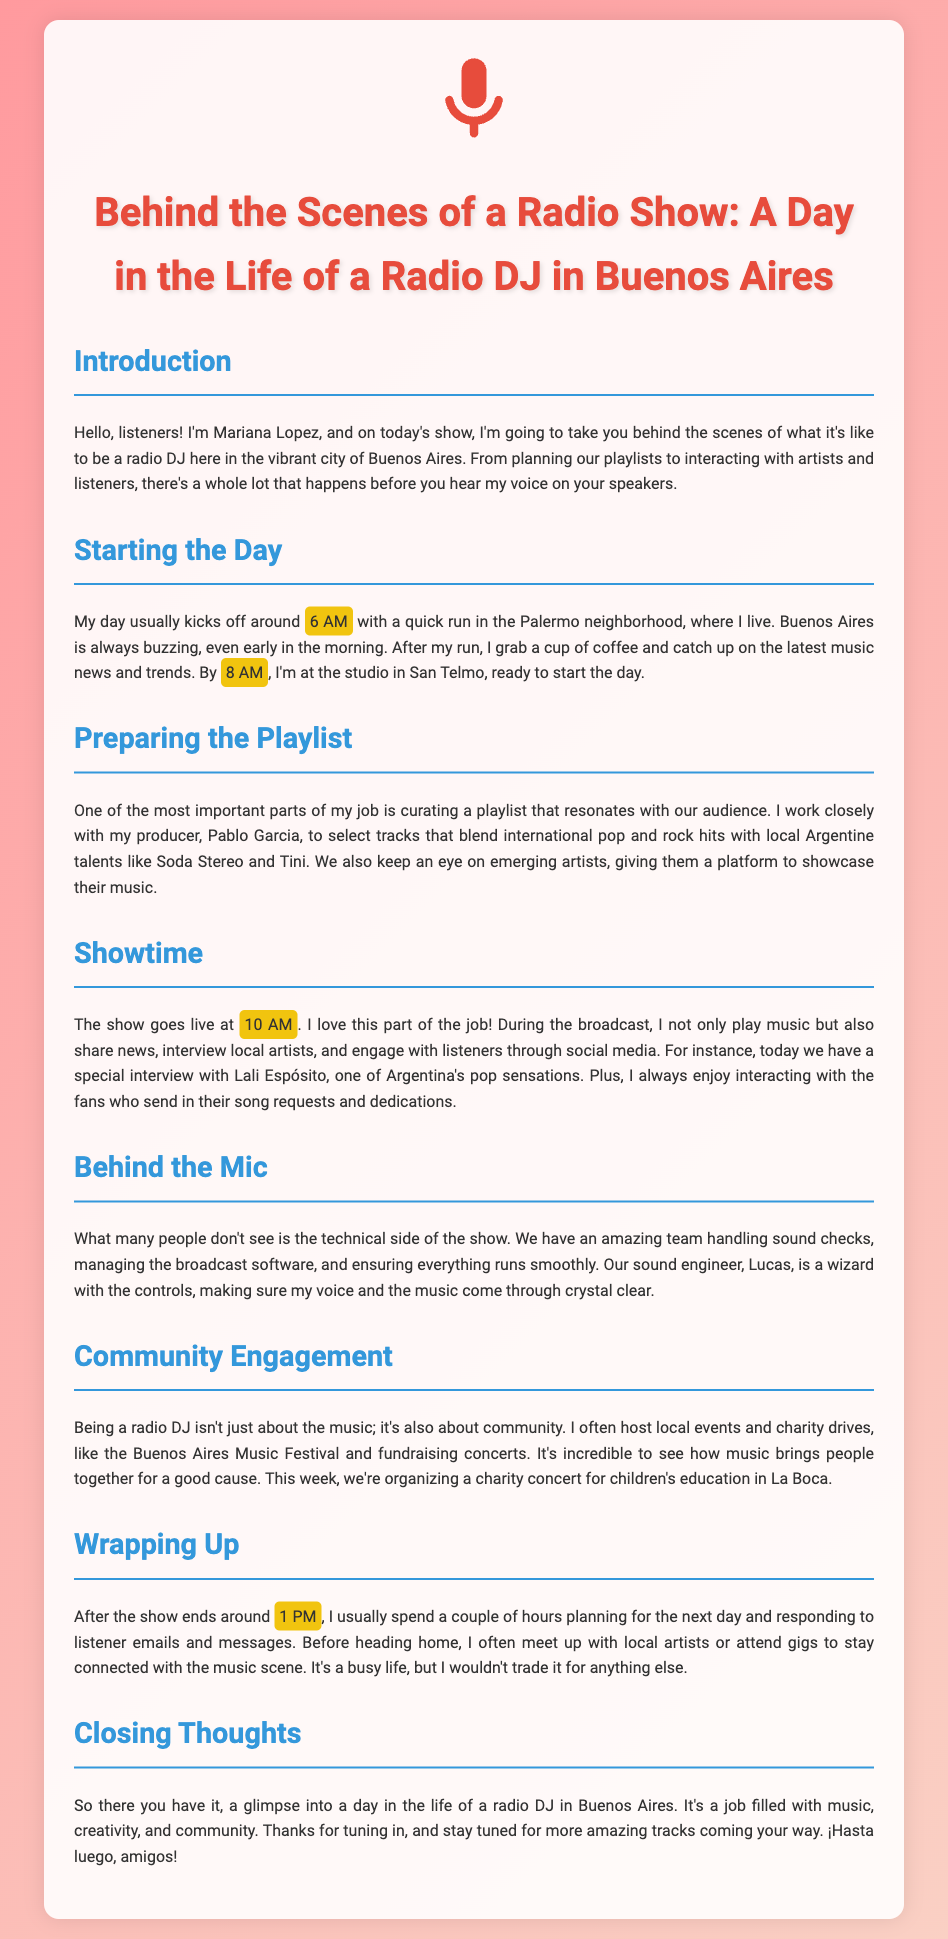What time does Mariana start her day? The document states that Mariana's day usually kicks off around 6 AM.
Answer: 6 AM Who is Mariana's producer? The transcript mentions that Mariana works closely with her producer, Pablo Garcia.
Answer: Pablo Garcia At what time does the show go live? According to the document, the show goes live at 10 AM.
Answer: 10 AM Which local artist is mentioned for a special interview? The document highlights that there is a special interview with Lali Espósito.
Answer: Lali Espósito What type of events does Mariana host? Mariana hosts local events and charity drives, as described in the section about community engagement.
Answer: Local events and charity drives What is one of the activities Mariana does after the show? The transcript mentions that after the show, she spends a couple of hours planning for the next day.
Answer: Planning for the next day What kind of music does Mariana blend in her playlists? Mariana’s playlists blend international pop and rock hits with local Argentine talents.
Answer: International pop and rock hits with local Argentine talents What is the purpose of the charity concert mentioned? The document states the charity concert is for children's education in La Boca.
Answer: Children's education in La Boca 